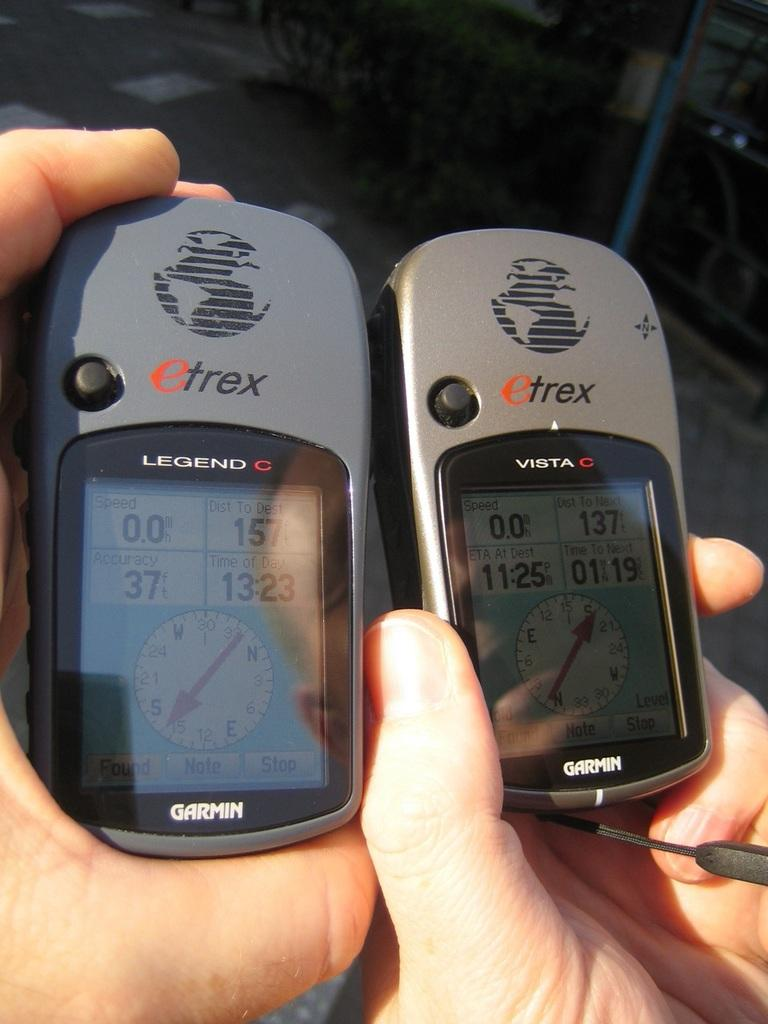<image>
Relay a brief, clear account of the picture shown. Two gps systems by Garmin are held next to each other. 